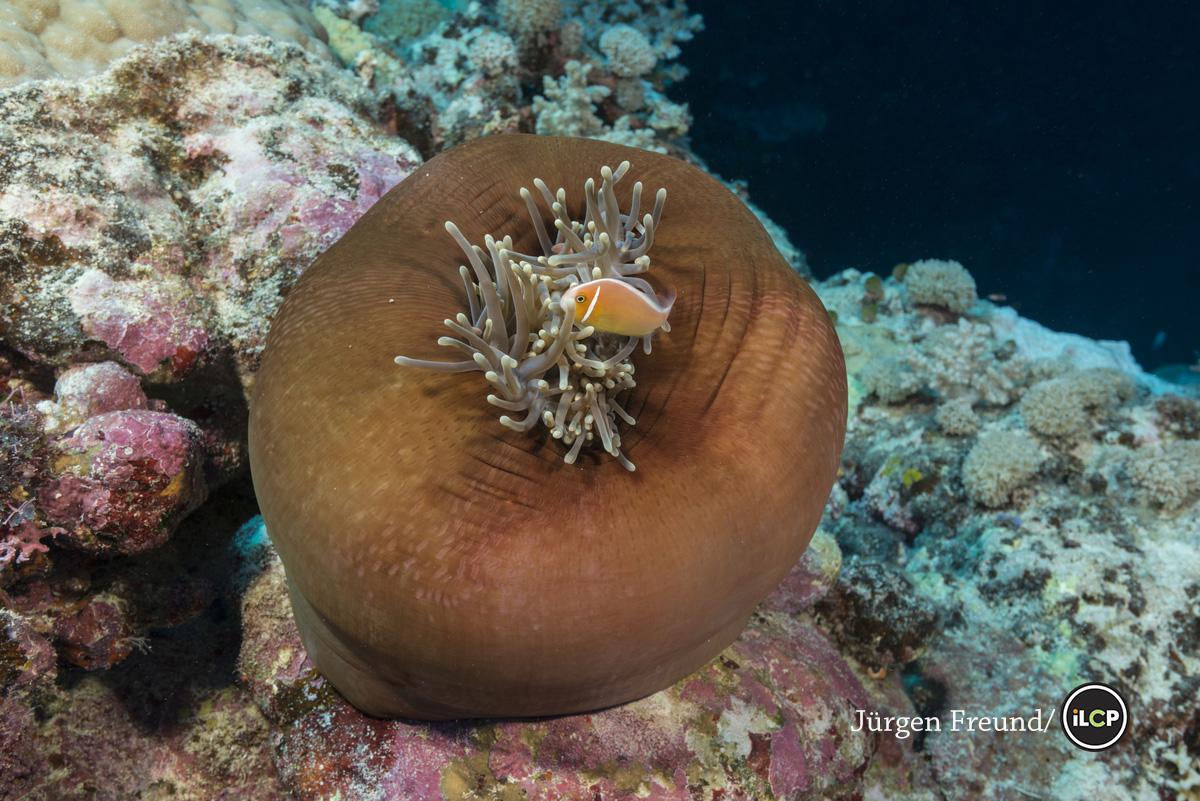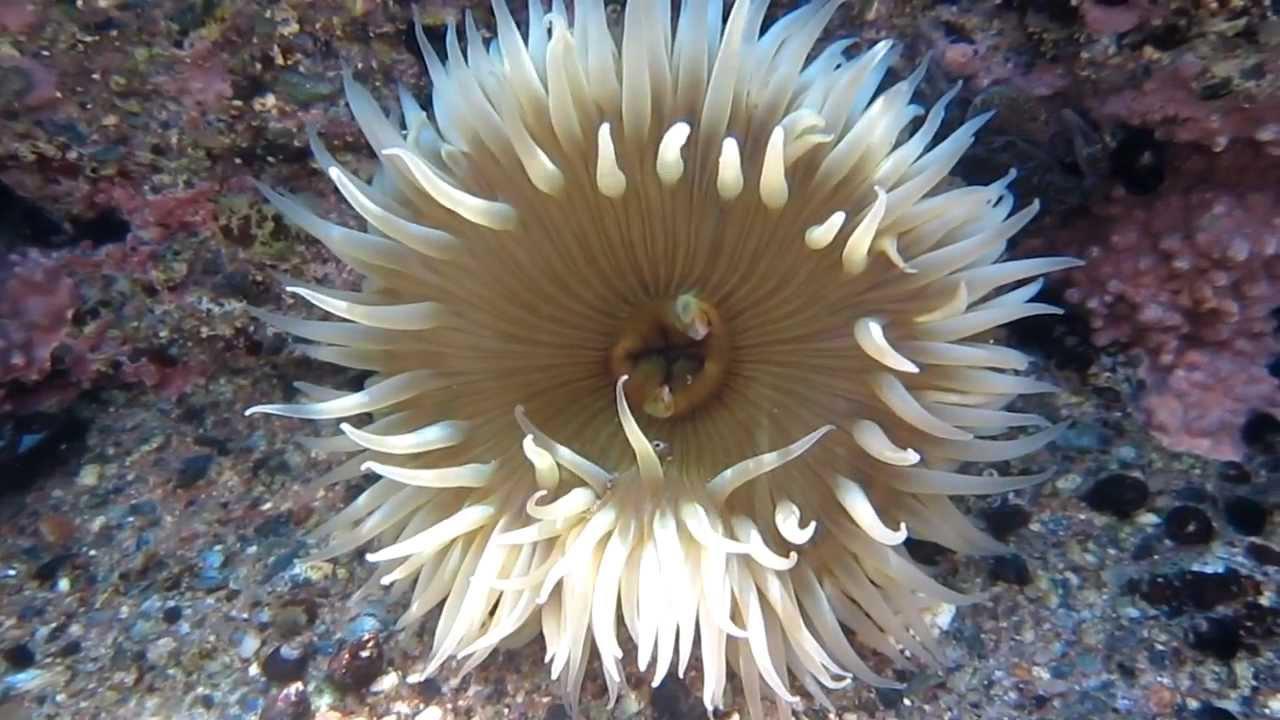The first image is the image on the left, the second image is the image on the right. Assess this claim about the two images: "One image shows anemone tendrils sprouting from the top of a large round shape, with at least one fish swimming near it.". Correct or not? Answer yes or no. Yes. The first image is the image on the left, the second image is the image on the right. For the images displayed, is the sentence "One of the anemones is spherical in shape." factually correct? Answer yes or no. Yes. 